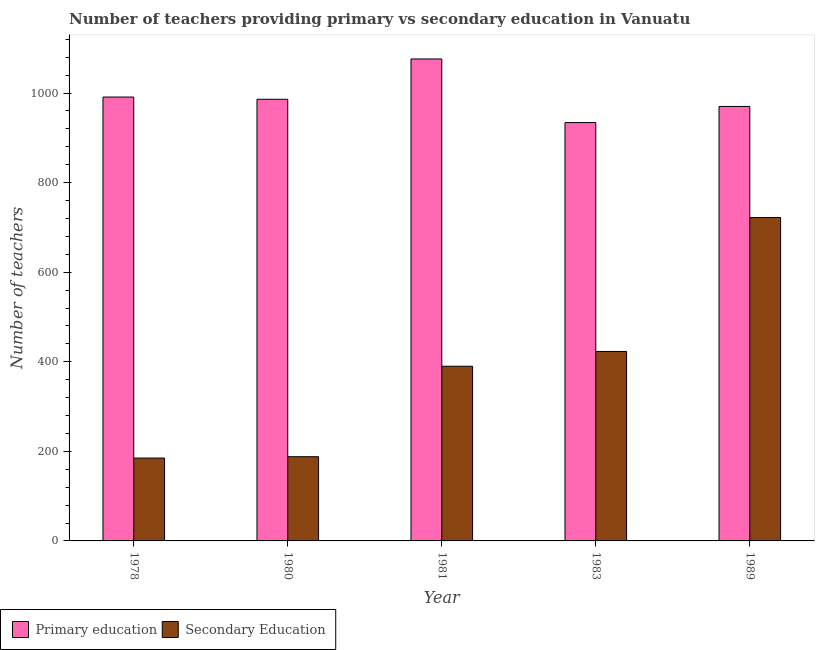How many different coloured bars are there?
Provide a short and direct response. 2. Are the number of bars per tick equal to the number of legend labels?
Provide a succinct answer. Yes. How many bars are there on the 2nd tick from the right?
Ensure brevity in your answer.  2. What is the number of secondary teachers in 1981?
Your answer should be very brief. 390. Across all years, what is the maximum number of primary teachers?
Your answer should be very brief. 1076. Across all years, what is the minimum number of secondary teachers?
Your answer should be very brief. 185. In which year was the number of primary teachers maximum?
Provide a succinct answer. 1981. In which year was the number of primary teachers minimum?
Your answer should be very brief. 1983. What is the total number of primary teachers in the graph?
Provide a succinct answer. 4957. What is the difference between the number of primary teachers in 1980 and that in 1981?
Make the answer very short. -90. What is the difference between the number of secondary teachers in 1980 and the number of primary teachers in 1981?
Provide a short and direct response. -202. What is the average number of secondary teachers per year?
Ensure brevity in your answer.  381.6. What is the ratio of the number of secondary teachers in 1978 to that in 1981?
Your response must be concise. 0.47. What is the difference between the highest and the second highest number of primary teachers?
Your answer should be very brief. 85. What is the difference between the highest and the lowest number of secondary teachers?
Provide a short and direct response. 537. Is the sum of the number of secondary teachers in 1978 and 1989 greater than the maximum number of primary teachers across all years?
Offer a terse response. Yes. What does the 1st bar from the left in 1983 represents?
Your answer should be very brief. Primary education. What does the 1st bar from the right in 1989 represents?
Ensure brevity in your answer.  Secondary Education. How are the legend labels stacked?
Provide a succinct answer. Horizontal. What is the title of the graph?
Give a very brief answer. Number of teachers providing primary vs secondary education in Vanuatu. Does "Male" appear as one of the legend labels in the graph?
Give a very brief answer. No. What is the label or title of the X-axis?
Make the answer very short. Year. What is the label or title of the Y-axis?
Ensure brevity in your answer.  Number of teachers. What is the Number of teachers in Primary education in 1978?
Your answer should be very brief. 991. What is the Number of teachers of Secondary Education in 1978?
Your answer should be compact. 185. What is the Number of teachers in Primary education in 1980?
Offer a very short reply. 986. What is the Number of teachers in Secondary Education in 1980?
Keep it short and to the point. 188. What is the Number of teachers in Primary education in 1981?
Offer a terse response. 1076. What is the Number of teachers of Secondary Education in 1981?
Ensure brevity in your answer.  390. What is the Number of teachers of Primary education in 1983?
Provide a succinct answer. 934. What is the Number of teachers of Secondary Education in 1983?
Provide a short and direct response. 423. What is the Number of teachers of Primary education in 1989?
Provide a succinct answer. 970. What is the Number of teachers of Secondary Education in 1989?
Give a very brief answer. 722. Across all years, what is the maximum Number of teachers of Primary education?
Your answer should be compact. 1076. Across all years, what is the maximum Number of teachers in Secondary Education?
Provide a short and direct response. 722. Across all years, what is the minimum Number of teachers in Primary education?
Offer a very short reply. 934. Across all years, what is the minimum Number of teachers in Secondary Education?
Keep it short and to the point. 185. What is the total Number of teachers in Primary education in the graph?
Provide a succinct answer. 4957. What is the total Number of teachers of Secondary Education in the graph?
Your answer should be very brief. 1908. What is the difference between the Number of teachers in Primary education in 1978 and that in 1980?
Ensure brevity in your answer.  5. What is the difference between the Number of teachers of Secondary Education in 1978 and that in 1980?
Provide a short and direct response. -3. What is the difference between the Number of teachers in Primary education in 1978 and that in 1981?
Provide a short and direct response. -85. What is the difference between the Number of teachers of Secondary Education in 1978 and that in 1981?
Provide a succinct answer. -205. What is the difference between the Number of teachers in Secondary Education in 1978 and that in 1983?
Provide a succinct answer. -238. What is the difference between the Number of teachers in Secondary Education in 1978 and that in 1989?
Make the answer very short. -537. What is the difference between the Number of teachers in Primary education in 1980 and that in 1981?
Offer a terse response. -90. What is the difference between the Number of teachers of Secondary Education in 1980 and that in 1981?
Give a very brief answer. -202. What is the difference between the Number of teachers of Primary education in 1980 and that in 1983?
Your response must be concise. 52. What is the difference between the Number of teachers of Secondary Education in 1980 and that in 1983?
Keep it short and to the point. -235. What is the difference between the Number of teachers of Secondary Education in 1980 and that in 1989?
Your response must be concise. -534. What is the difference between the Number of teachers of Primary education in 1981 and that in 1983?
Your response must be concise. 142. What is the difference between the Number of teachers of Secondary Education in 1981 and that in 1983?
Ensure brevity in your answer.  -33. What is the difference between the Number of teachers in Primary education in 1981 and that in 1989?
Your response must be concise. 106. What is the difference between the Number of teachers in Secondary Education in 1981 and that in 1989?
Your response must be concise. -332. What is the difference between the Number of teachers in Primary education in 1983 and that in 1989?
Give a very brief answer. -36. What is the difference between the Number of teachers in Secondary Education in 1983 and that in 1989?
Ensure brevity in your answer.  -299. What is the difference between the Number of teachers of Primary education in 1978 and the Number of teachers of Secondary Education in 1980?
Give a very brief answer. 803. What is the difference between the Number of teachers in Primary education in 1978 and the Number of teachers in Secondary Education in 1981?
Your answer should be compact. 601. What is the difference between the Number of teachers of Primary education in 1978 and the Number of teachers of Secondary Education in 1983?
Your response must be concise. 568. What is the difference between the Number of teachers in Primary education in 1978 and the Number of teachers in Secondary Education in 1989?
Your response must be concise. 269. What is the difference between the Number of teachers of Primary education in 1980 and the Number of teachers of Secondary Education in 1981?
Offer a terse response. 596. What is the difference between the Number of teachers of Primary education in 1980 and the Number of teachers of Secondary Education in 1983?
Your answer should be compact. 563. What is the difference between the Number of teachers in Primary education in 1980 and the Number of teachers in Secondary Education in 1989?
Your response must be concise. 264. What is the difference between the Number of teachers in Primary education in 1981 and the Number of teachers in Secondary Education in 1983?
Make the answer very short. 653. What is the difference between the Number of teachers of Primary education in 1981 and the Number of teachers of Secondary Education in 1989?
Keep it short and to the point. 354. What is the difference between the Number of teachers in Primary education in 1983 and the Number of teachers in Secondary Education in 1989?
Your answer should be compact. 212. What is the average Number of teachers in Primary education per year?
Give a very brief answer. 991.4. What is the average Number of teachers of Secondary Education per year?
Give a very brief answer. 381.6. In the year 1978, what is the difference between the Number of teachers of Primary education and Number of teachers of Secondary Education?
Your response must be concise. 806. In the year 1980, what is the difference between the Number of teachers of Primary education and Number of teachers of Secondary Education?
Offer a terse response. 798. In the year 1981, what is the difference between the Number of teachers of Primary education and Number of teachers of Secondary Education?
Your answer should be compact. 686. In the year 1983, what is the difference between the Number of teachers in Primary education and Number of teachers in Secondary Education?
Your answer should be very brief. 511. In the year 1989, what is the difference between the Number of teachers of Primary education and Number of teachers of Secondary Education?
Ensure brevity in your answer.  248. What is the ratio of the Number of teachers in Secondary Education in 1978 to that in 1980?
Provide a short and direct response. 0.98. What is the ratio of the Number of teachers of Primary education in 1978 to that in 1981?
Your answer should be very brief. 0.92. What is the ratio of the Number of teachers in Secondary Education in 1978 to that in 1981?
Keep it short and to the point. 0.47. What is the ratio of the Number of teachers of Primary education in 1978 to that in 1983?
Provide a short and direct response. 1.06. What is the ratio of the Number of teachers in Secondary Education in 1978 to that in 1983?
Provide a succinct answer. 0.44. What is the ratio of the Number of teachers of Primary education in 1978 to that in 1989?
Make the answer very short. 1.02. What is the ratio of the Number of teachers of Secondary Education in 1978 to that in 1989?
Your answer should be very brief. 0.26. What is the ratio of the Number of teachers of Primary education in 1980 to that in 1981?
Make the answer very short. 0.92. What is the ratio of the Number of teachers in Secondary Education in 1980 to that in 1981?
Offer a terse response. 0.48. What is the ratio of the Number of teachers in Primary education in 1980 to that in 1983?
Ensure brevity in your answer.  1.06. What is the ratio of the Number of teachers of Secondary Education in 1980 to that in 1983?
Offer a very short reply. 0.44. What is the ratio of the Number of teachers of Primary education in 1980 to that in 1989?
Offer a very short reply. 1.02. What is the ratio of the Number of teachers of Secondary Education in 1980 to that in 1989?
Give a very brief answer. 0.26. What is the ratio of the Number of teachers in Primary education in 1981 to that in 1983?
Provide a short and direct response. 1.15. What is the ratio of the Number of teachers in Secondary Education in 1981 to that in 1983?
Provide a short and direct response. 0.92. What is the ratio of the Number of teachers in Primary education in 1981 to that in 1989?
Ensure brevity in your answer.  1.11. What is the ratio of the Number of teachers of Secondary Education in 1981 to that in 1989?
Your answer should be very brief. 0.54. What is the ratio of the Number of teachers of Primary education in 1983 to that in 1989?
Make the answer very short. 0.96. What is the ratio of the Number of teachers of Secondary Education in 1983 to that in 1989?
Offer a terse response. 0.59. What is the difference between the highest and the second highest Number of teachers of Primary education?
Your answer should be compact. 85. What is the difference between the highest and the second highest Number of teachers of Secondary Education?
Your response must be concise. 299. What is the difference between the highest and the lowest Number of teachers of Primary education?
Make the answer very short. 142. What is the difference between the highest and the lowest Number of teachers of Secondary Education?
Offer a terse response. 537. 